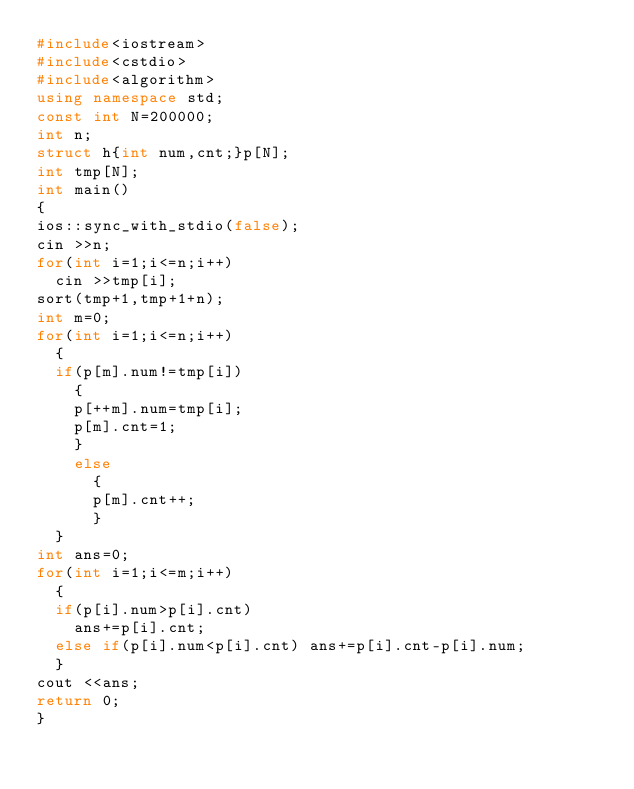Convert code to text. <code><loc_0><loc_0><loc_500><loc_500><_C++_>#include<iostream>
#include<cstdio>
#include<algorithm>
using namespace std;
const int N=200000;
int n;
struct h{int num,cnt;}p[N];
int tmp[N];
int main()
{
ios::sync_with_stdio(false);
cin >>n;
for(int i=1;i<=n;i++)
	cin >>tmp[i];
sort(tmp+1,tmp+1+n);
int m=0;
for(int i=1;i<=n;i++)
	{
	if(p[m].num!=tmp[i])
		{
		p[++m].num=tmp[i];
		p[m].cnt=1;
		}
		else 
			{
			p[m].cnt++;
			}
	}
int ans=0;
for(int i=1;i<=m;i++)
	{
	if(p[i].num>p[i].cnt)
		ans+=p[i].cnt;
	else if(p[i].num<p[i].cnt) ans+=p[i].cnt-p[i].num;
	}
cout <<ans;
return 0;
}
</code> 